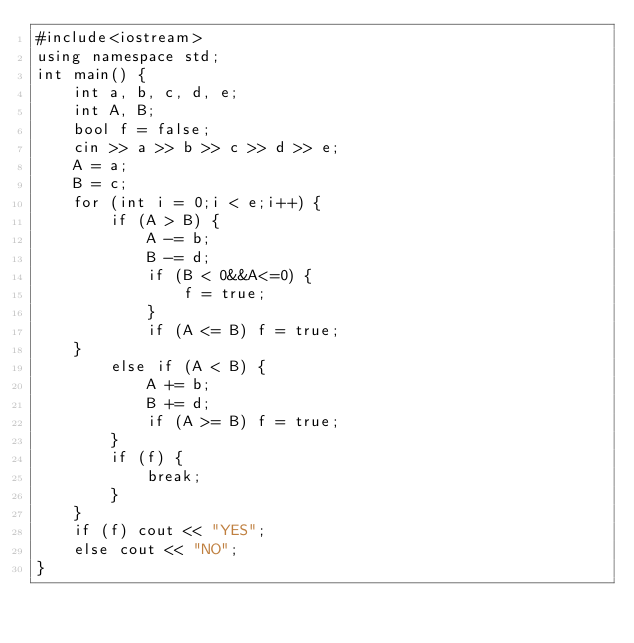<code> <loc_0><loc_0><loc_500><loc_500><_C++_>#include<iostream>
using namespace std;
int main() {
	int a, b, c, d, e;
	int A, B;
	bool f = false;
	cin >> a >> b >> c >> d >> e;
	A = a;
	B = c;
	for (int i = 0;i < e;i++) {
		if (A > B) {
			A -= b;
			B -= d;
			if (B < 0&&A<=0) {
				f = true;
			}
			if (A <= B) f = true;
	}
		else if (A < B) {
			A += b;
			B += d;
			if (A >= B) f = true;
		}
		if (f) {
			break;
		}
	}
	if (f) cout << "YES";
	else cout << "NO";
}</code> 